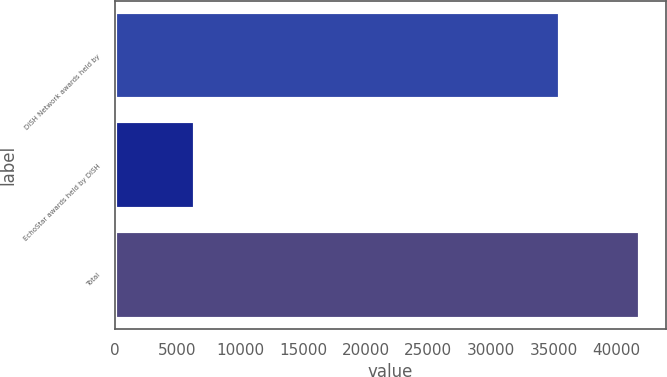Convert chart. <chart><loc_0><loc_0><loc_500><loc_500><bar_chart><fcel>DISH Network awards held by<fcel>EchoStar awards held by DISH<fcel>Total<nl><fcel>35508<fcel>6389<fcel>41897<nl></chart> 